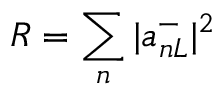Convert formula to latex. <formula><loc_0><loc_0><loc_500><loc_500>R = \sum _ { n } | a _ { n L } ^ { - } | ^ { 2 }</formula> 